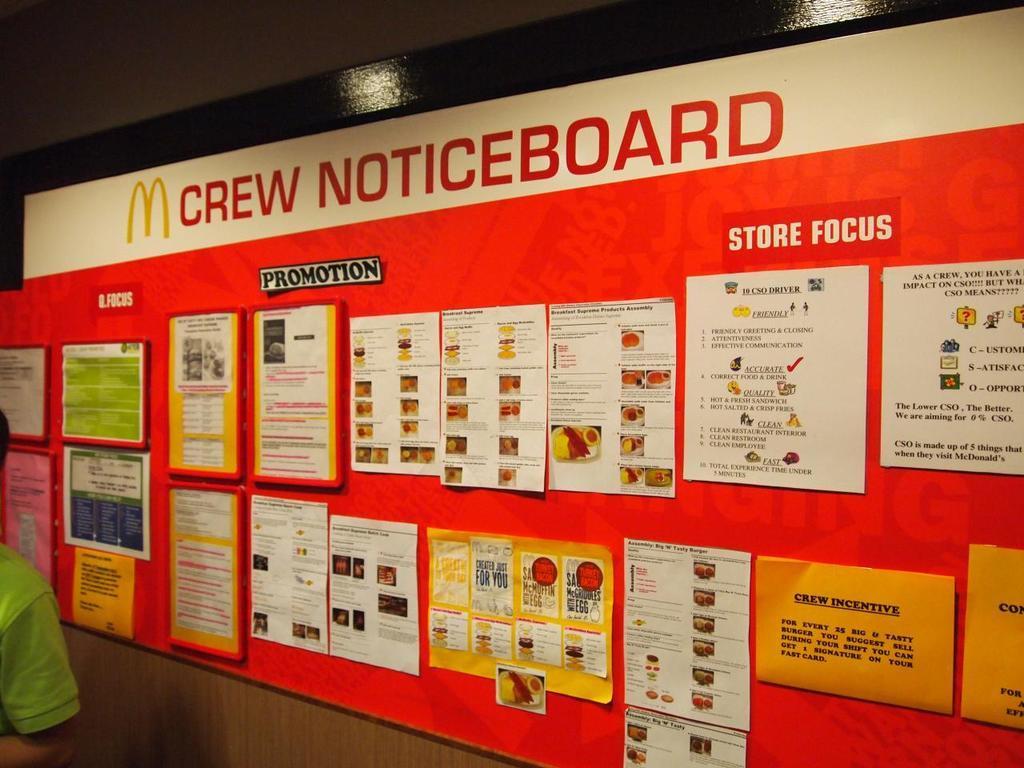Describe this image in one or two sentences. The picture consists of a notice board, in the board there are posters, papers attached. On the left there is a person. At the top it is well. 